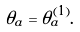<formula> <loc_0><loc_0><loc_500><loc_500>\theta _ { a } = \theta _ { a } ^ { ( 1 ) } .</formula> 